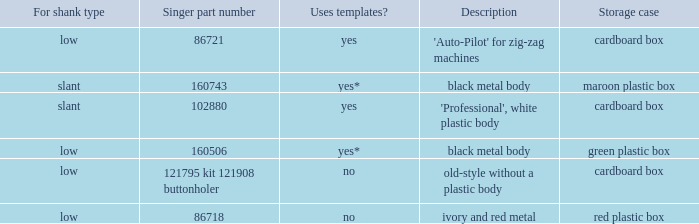What's the shank type of the buttonholer with red plastic box as storage case? Low. Write the full table. {'header': ['For shank type', 'Singer part number', 'Uses templates?', 'Description', 'Storage case'], 'rows': [['low', '86721', 'yes', "'Auto-Pilot' for zig-zag machines", 'cardboard box'], ['slant', '160743', 'yes*', 'black metal body', 'maroon plastic box'], ['slant', '102880', 'yes', "'Professional', white plastic body", 'cardboard box'], ['low', '160506', 'yes*', 'black metal body', 'green plastic box'], ['low', '121795 kit 121908 buttonholer', 'no', 'old-style without a plastic body', 'cardboard box'], ['low', '86718', 'no', 'ivory and red metal', 'red plastic box']]} 